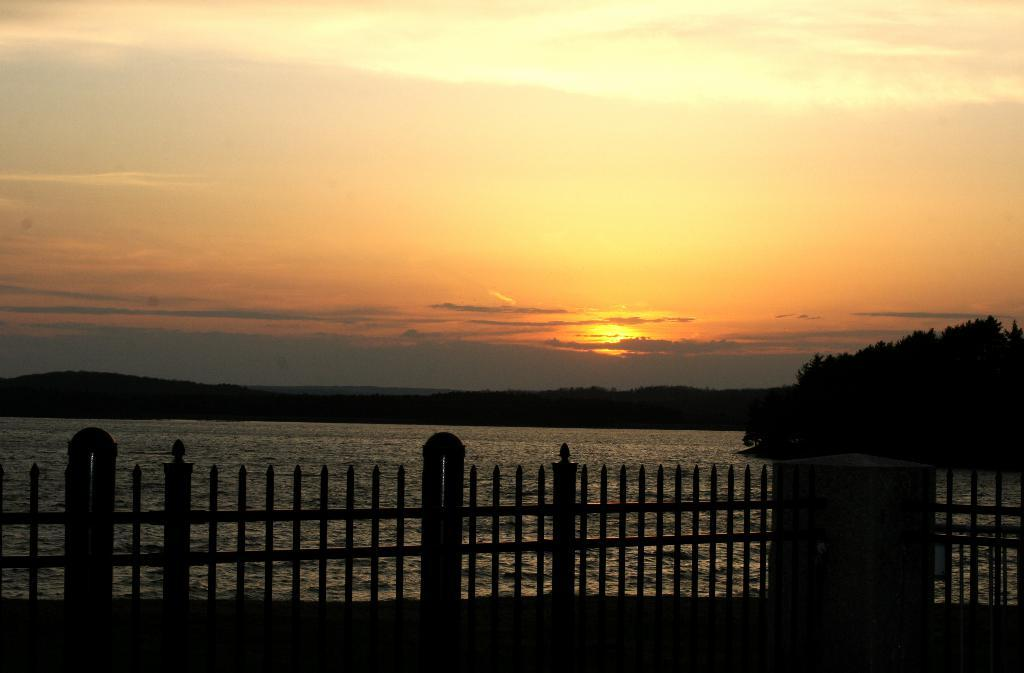What body of water is visible in the image? There is a lake in the image. What is located in front of the lake? There is a fence in front of the lake. What can be seen in the sky in the image? The sky is visible in the image, and there is a sunset. What type of vegetation is present in the image? Trees are present in the image. What type of frame is around the sunset in the image? There is no frame around the sunset in the image; it is a natural occurrence in the sky. 